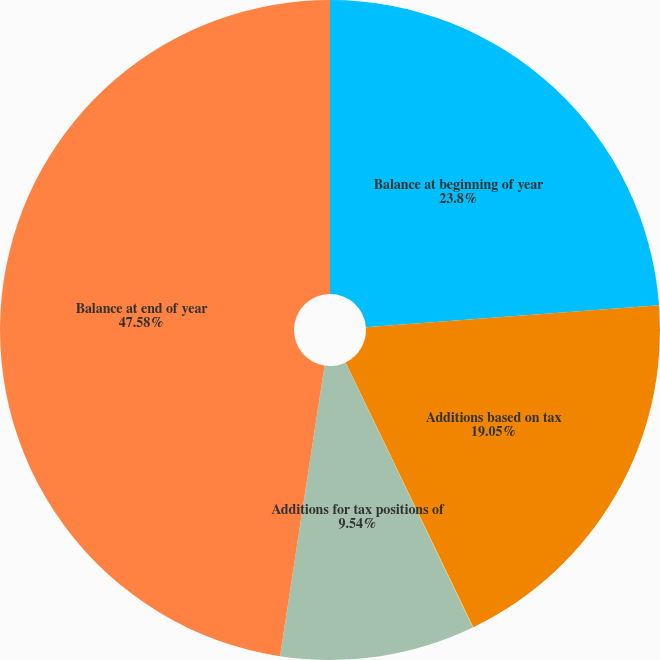<chart> <loc_0><loc_0><loc_500><loc_500><pie_chart><fcel>Balance at beginning of year<fcel>Additions based on tax<fcel>Reductions for tax positions<fcel>Additions for tax positions of<fcel>Balance at end of year<nl><fcel>23.8%<fcel>19.05%<fcel>0.03%<fcel>9.54%<fcel>47.58%<nl></chart> 